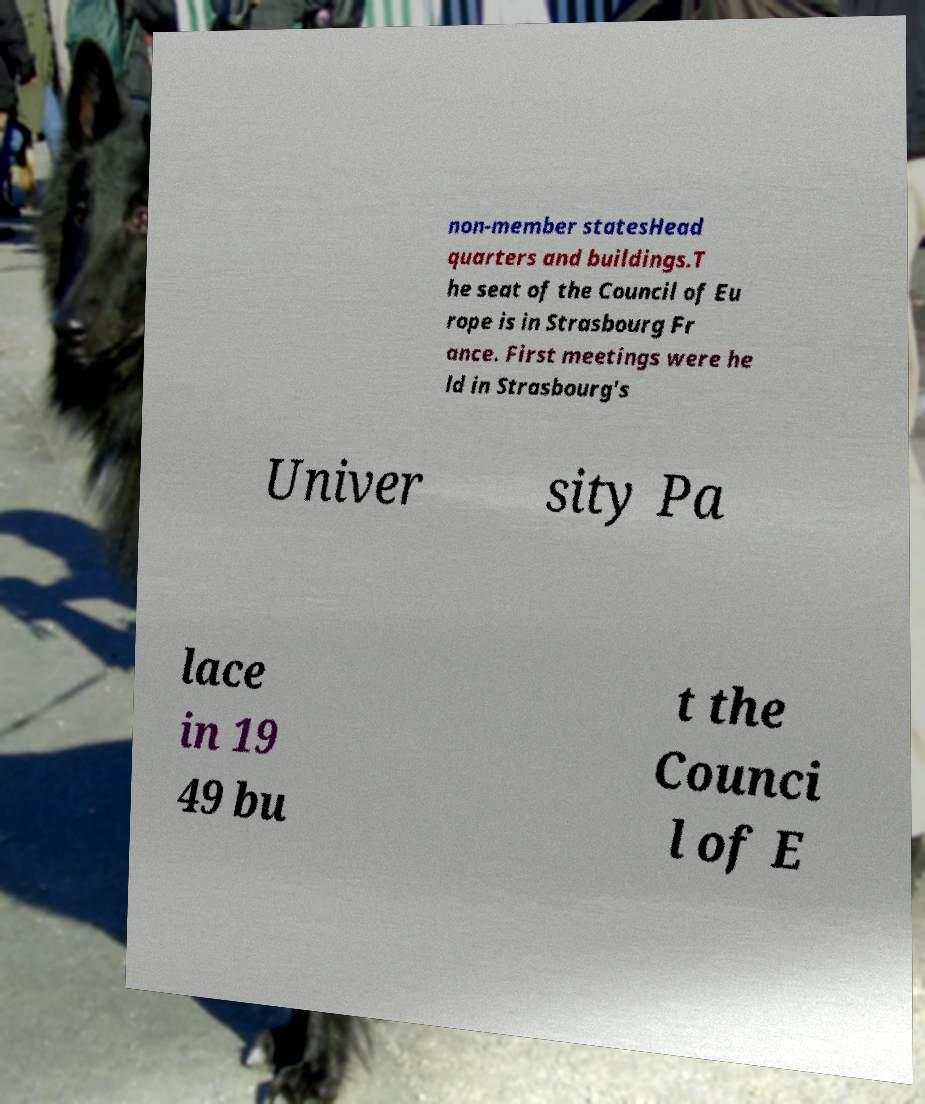Could you extract and type out the text from this image? non-member statesHead quarters and buildings.T he seat of the Council of Eu rope is in Strasbourg Fr ance. First meetings were he ld in Strasbourg's Univer sity Pa lace in 19 49 bu t the Counci l of E 